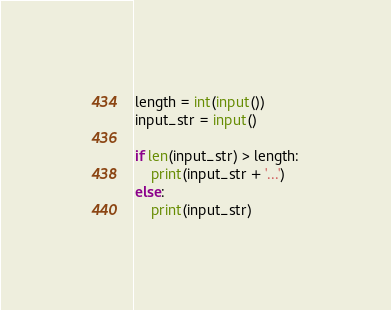Convert code to text. <code><loc_0><loc_0><loc_500><loc_500><_Python_>length = int(input())
input_str = input()

if len(input_str) > length:
    print(input_str + '...')
else:
    print(input_str)</code> 